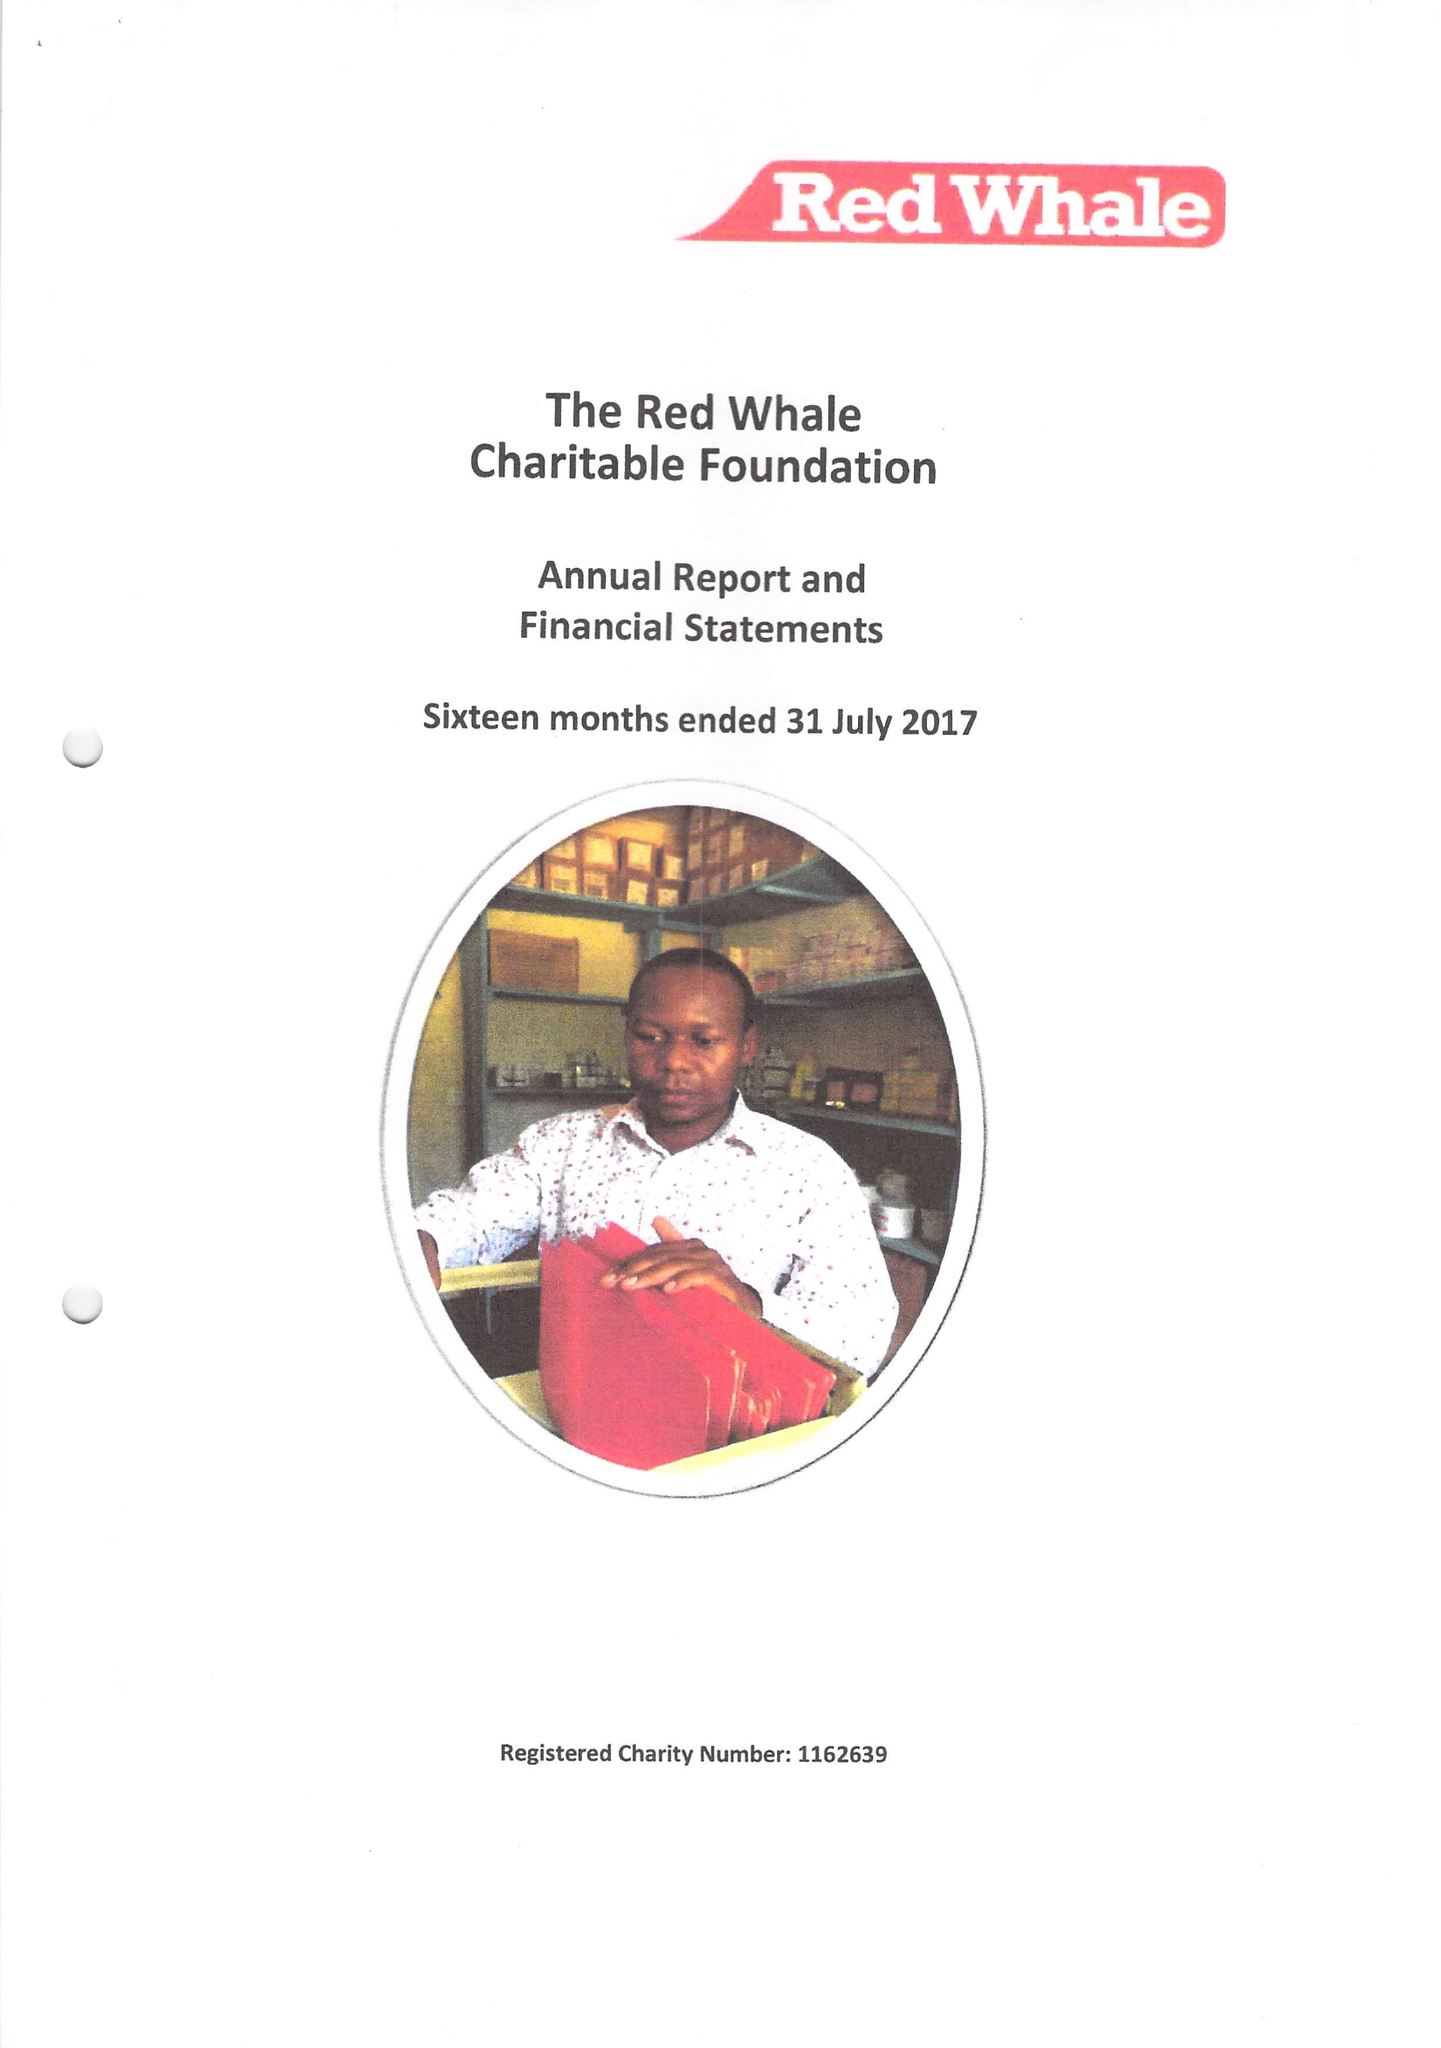What is the value for the spending_annually_in_british_pounds?
Answer the question using a single word or phrase. 45000.00 